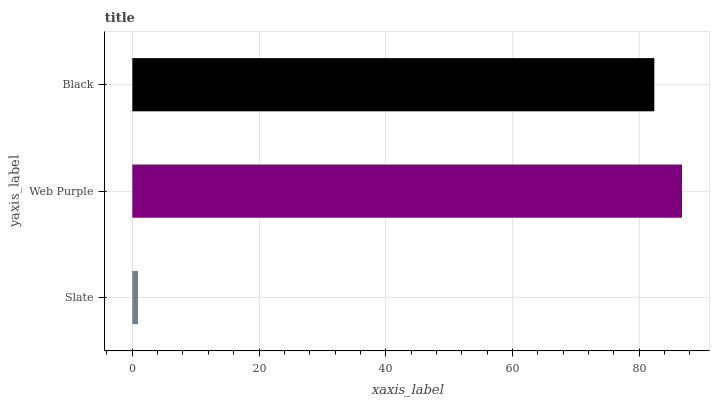Is Slate the minimum?
Answer yes or no. Yes. Is Web Purple the maximum?
Answer yes or no. Yes. Is Black the minimum?
Answer yes or no. No. Is Black the maximum?
Answer yes or no. No. Is Web Purple greater than Black?
Answer yes or no. Yes. Is Black less than Web Purple?
Answer yes or no. Yes. Is Black greater than Web Purple?
Answer yes or no. No. Is Web Purple less than Black?
Answer yes or no. No. Is Black the high median?
Answer yes or no. Yes. Is Black the low median?
Answer yes or no. Yes. Is Slate the high median?
Answer yes or no. No. Is Slate the low median?
Answer yes or no. No. 